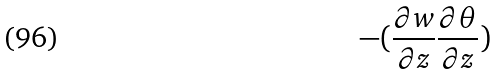<formula> <loc_0><loc_0><loc_500><loc_500>- ( \frac { \partial w } { \partial z } \frac { \partial \theta } { \partial z } )</formula> 